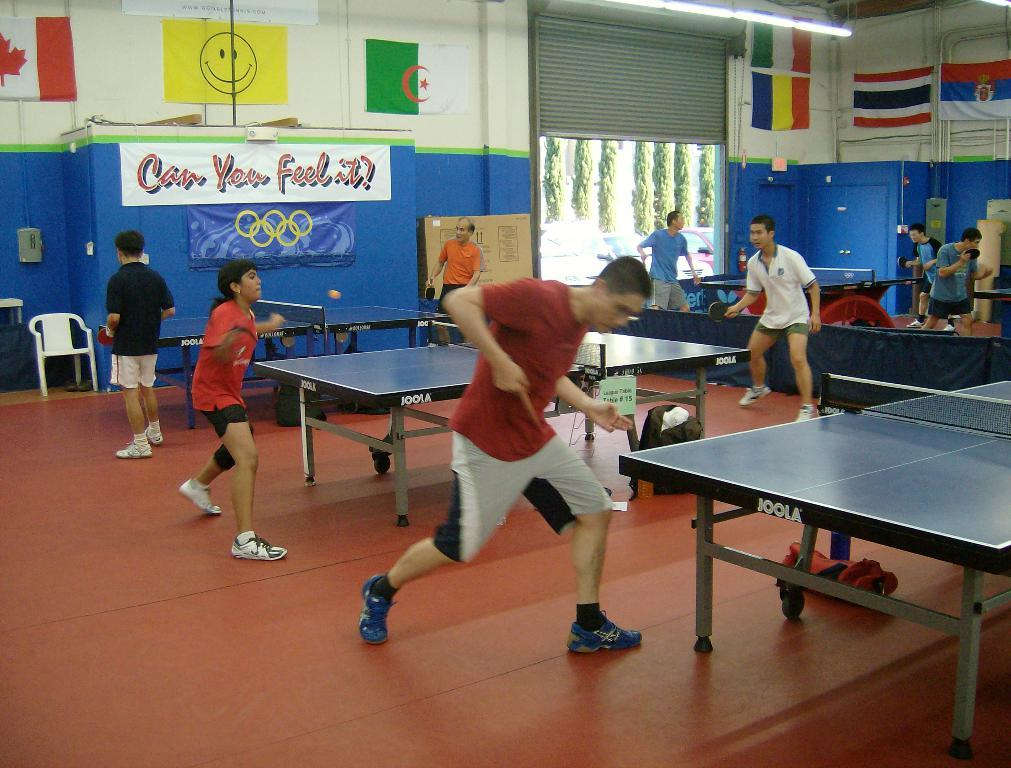What activity are the people in the image engaged in? There is a group of people playing table tennis in the image. What objects are near the table tennis table? There are bags near the table tennis table. Can you describe the background of the image? There is a chair, a wall with a poster, a shutter, and flags in the background. What type of church can be seen in the background of the image? There is no church present in the background of the image. How many oranges are visible on the table tennis table? There are no oranges visible in the image. 